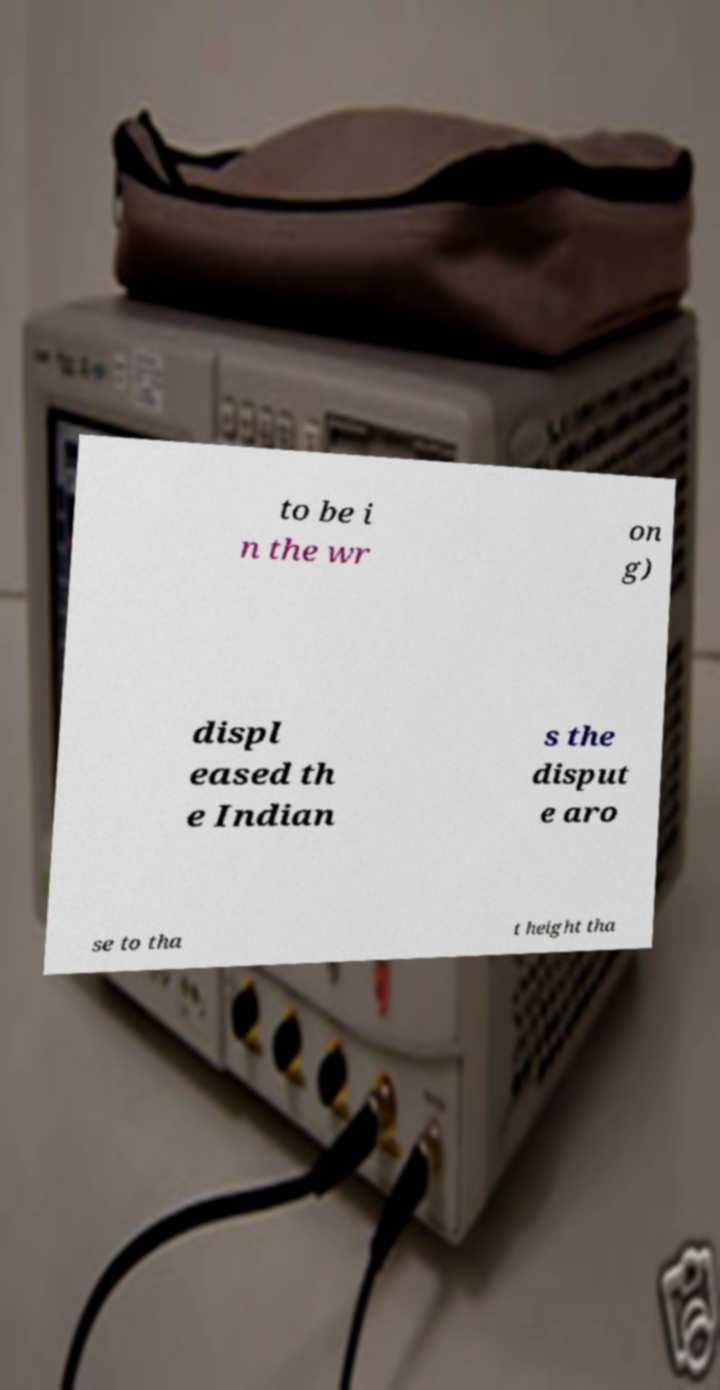Please read and relay the text visible in this image. What does it say? to be i n the wr on g) displ eased th e Indian s the disput e aro se to tha t height tha 